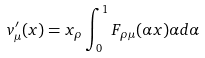<formula> <loc_0><loc_0><loc_500><loc_500>v _ { \mu } ^ { \prime } ( x ) = x _ { \rho } \int ^ { 1 } _ { 0 } F _ { \rho \mu } ( \alpha x ) \alpha d \alpha</formula> 